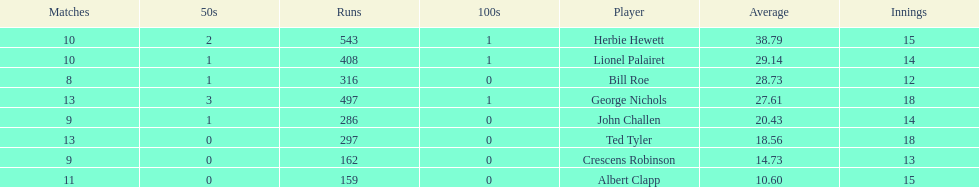What is the lowest amount of runs anyone possesses? 159. 